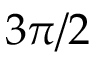Convert formula to latex. <formula><loc_0><loc_0><loc_500><loc_500>3 \pi / 2</formula> 